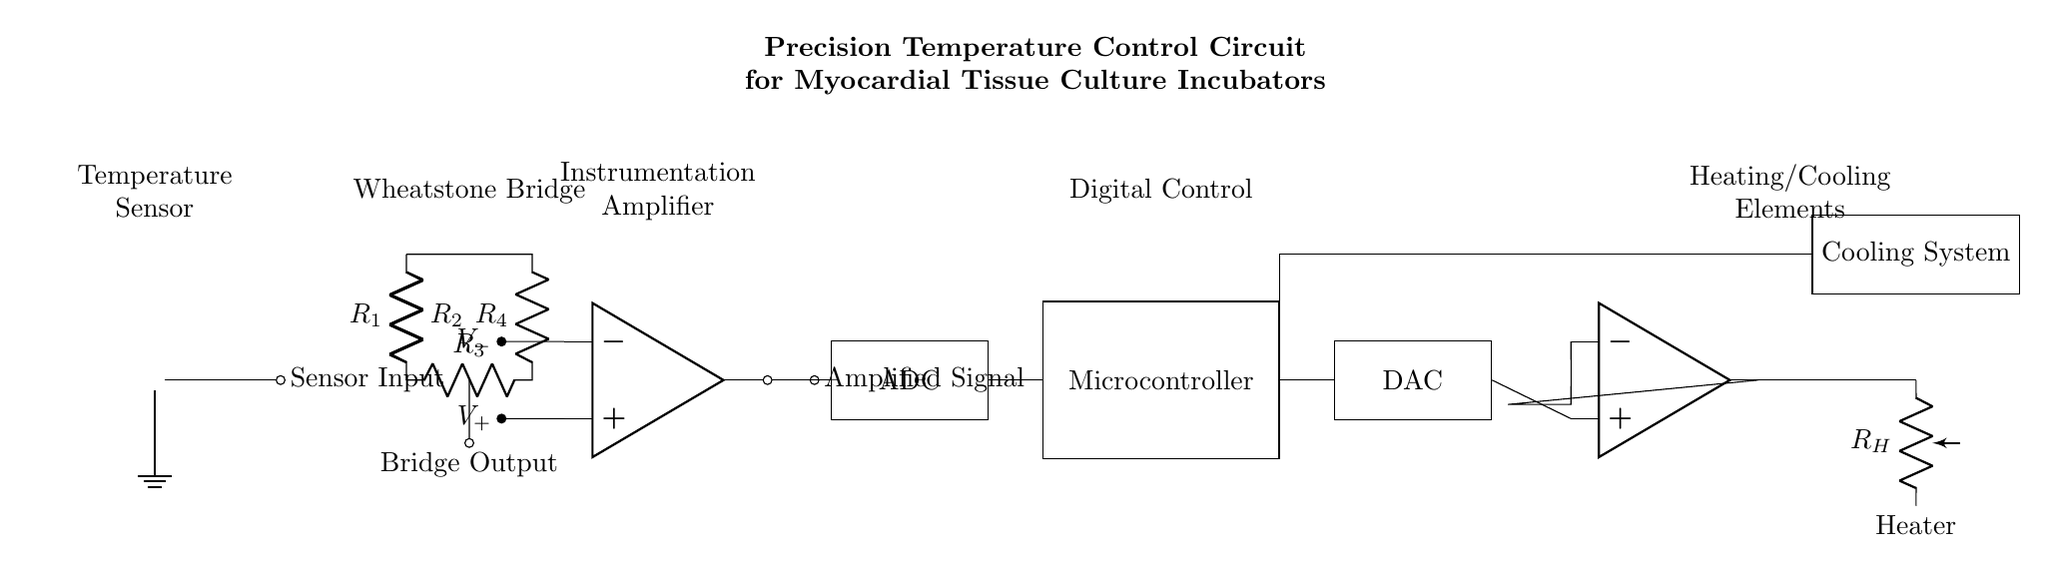What component measures temperature? The temperature sensor is the component that detects temperature changes in the circuit. It is represented at the start of the diagram.
Answer: Temperature Sensor What type of amplifier is used to amplify the signal? An instrumentation amplifier is used in the circuit to amplify the output signal from the Wheatstone bridge. It is shown after the bridge component in the diagram.
Answer: Instrumentation Amplifier How many resistors are in the Wheatstone bridge? There are four resistors labeled as R1, R2, R3, and R4 in the Wheatstone bridge configuration shown in the circuit. Each plays a role in balancing the bridge.
Answer: Four What is the function of the microcontroller? The microcontroller processes the amplified signal from the instrumentation amplifier and controls the digital output for further processing by the DAC. It is another key component in the diagram.
Answer: Digital Control Which element controls the heating in the circuit? The heater, labeled as R_H in the diagram, is the element responsible for heating the environment for the myocardial tissue culture. It receives signals from the power amplifier.
Answer: Heater How does the cooling system interact with the microcontroller? The cooling system is connected to the microcontroller through a line that indicates control signals are sent from the microcontroller to the cooling system, suggesting it adjusts cooling based on the processed temperature data.
Answer: Communication What is the role of the DAC in this circuit? The DAC, or Digital-to-Analog Converter, converts the digital signals from the microcontroller into analog signals to control the power amplifier, which in turn adjusts the heating or cooling elements based on the temperature readings.
Answer: Signal Conversion 